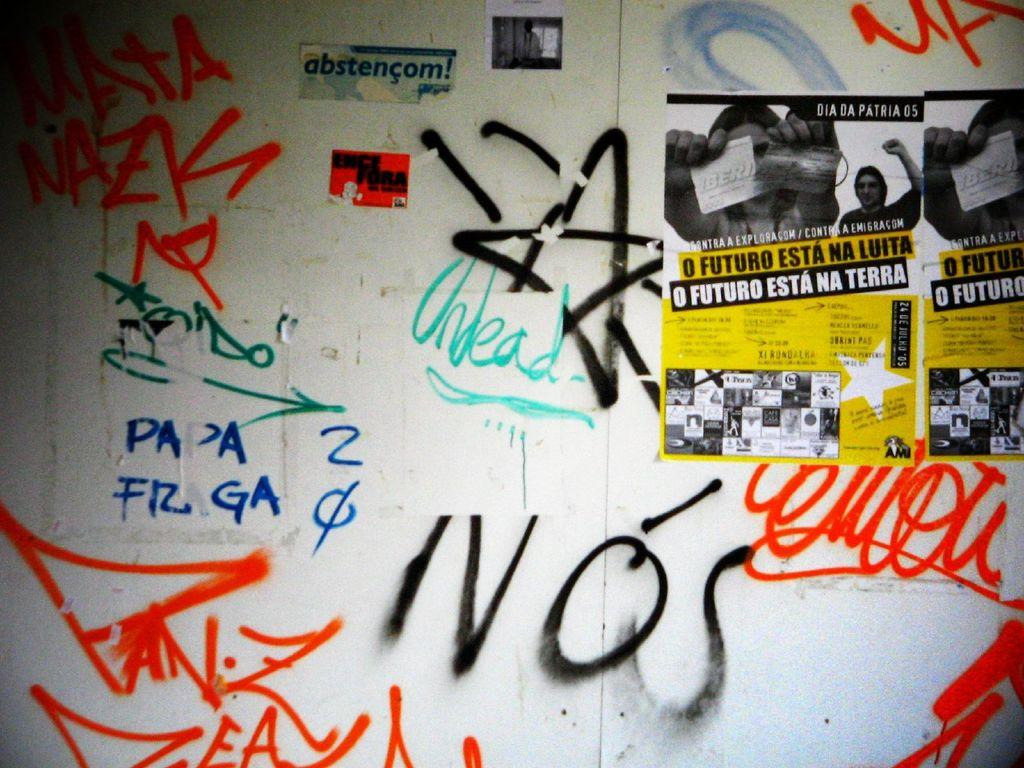What can be seen on the posters in the image? There are posters with text in the image. Can you describe the text on the wall in the image? There is text on the wall in the image. How many rabbits are sitting on the books in the image? There are no books or rabbits present in the image. What color is the paint on the wall in the image? There is no paint visible in the image; only text on the wall is present. 